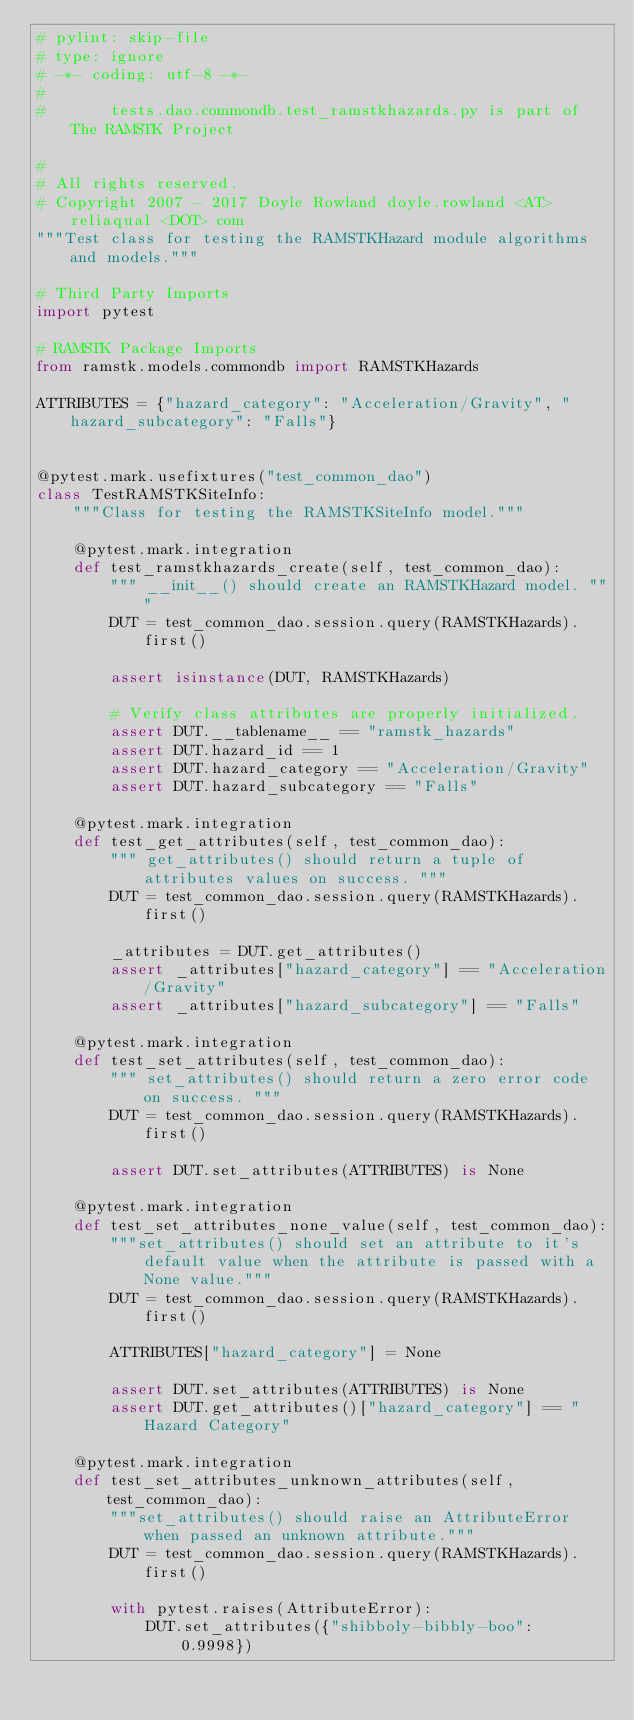<code> <loc_0><loc_0><loc_500><loc_500><_Python_># pylint: skip-file
# type: ignore
# -*- coding: utf-8 -*-
#
#       tests.dao.commondb.test_ramstkhazards.py is part of The RAMSTK Project

#
# All rights reserved.
# Copyright 2007 - 2017 Doyle Rowland doyle.rowland <AT> reliaqual <DOT> com
"""Test class for testing the RAMSTKHazard module algorithms and models."""

# Third Party Imports
import pytest

# RAMSTK Package Imports
from ramstk.models.commondb import RAMSTKHazards

ATTRIBUTES = {"hazard_category": "Acceleration/Gravity", "hazard_subcategory": "Falls"}


@pytest.mark.usefixtures("test_common_dao")
class TestRAMSTKSiteInfo:
    """Class for testing the RAMSTKSiteInfo model."""

    @pytest.mark.integration
    def test_ramstkhazards_create(self, test_common_dao):
        """ __init__() should create an RAMSTKHazard model. """
        DUT = test_common_dao.session.query(RAMSTKHazards).first()

        assert isinstance(DUT, RAMSTKHazards)

        # Verify class attributes are properly initialized.
        assert DUT.__tablename__ == "ramstk_hazards"
        assert DUT.hazard_id == 1
        assert DUT.hazard_category == "Acceleration/Gravity"
        assert DUT.hazard_subcategory == "Falls"

    @pytest.mark.integration
    def test_get_attributes(self, test_common_dao):
        """ get_attributes() should return a tuple of attributes values on success. """
        DUT = test_common_dao.session.query(RAMSTKHazards).first()

        _attributes = DUT.get_attributes()
        assert _attributes["hazard_category"] == "Acceleration/Gravity"
        assert _attributes["hazard_subcategory"] == "Falls"

    @pytest.mark.integration
    def test_set_attributes(self, test_common_dao):
        """ set_attributes() should return a zero error code on success. """
        DUT = test_common_dao.session.query(RAMSTKHazards).first()

        assert DUT.set_attributes(ATTRIBUTES) is None

    @pytest.mark.integration
    def test_set_attributes_none_value(self, test_common_dao):
        """set_attributes() should set an attribute to it's default value when the attribute is passed with a None value."""
        DUT = test_common_dao.session.query(RAMSTKHazards).first()

        ATTRIBUTES["hazard_category"] = None

        assert DUT.set_attributes(ATTRIBUTES) is None
        assert DUT.get_attributes()["hazard_category"] == "Hazard Category"

    @pytest.mark.integration
    def test_set_attributes_unknown_attributes(self, test_common_dao):
        """set_attributes() should raise an AttributeError when passed an unknown attribute."""
        DUT = test_common_dao.session.query(RAMSTKHazards).first()

        with pytest.raises(AttributeError):
            DUT.set_attributes({"shibboly-bibbly-boo": 0.9998})
</code> 